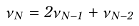<formula> <loc_0><loc_0><loc_500><loc_500>\nu _ { N } = 2 \nu _ { N - 1 } + \nu _ { N - 2 }</formula> 